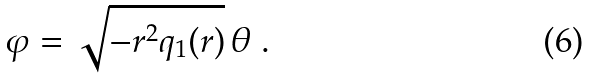Convert formula to latex. <formula><loc_0><loc_0><loc_500><loc_500>\varphi = \sqrt { - r ^ { 2 } q _ { 1 } ( r ) } \, \theta \ .</formula> 